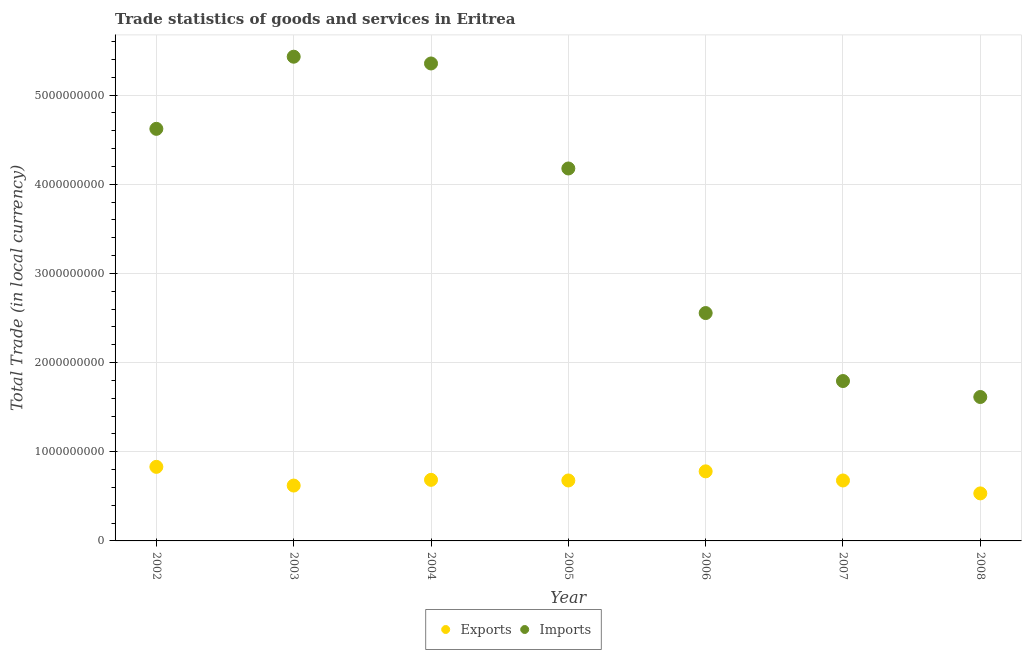Is the number of dotlines equal to the number of legend labels?
Provide a short and direct response. Yes. What is the imports of goods and services in 2005?
Provide a succinct answer. 4.18e+09. Across all years, what is the maximum export of goods and services?
Give a very brief answer. 8.31e+08. Across all years, what is the minimum imports of goods and services?
Ensure brevity in your answer.  1.61e+09. What is the total imports of goods and services in the graph?
Your answer should be compact. 2.55e+1. What is the difference between the export of goods and services in 2005 and that in 2006?
Make the answer very short. -1.02e+08. What is the difference between the imports of goods and services in 2003 and the export of goods and services in 2007?
Provide a short and direct response. 4.75e+09. What is the average imports of goods and services per year?
Your response must be concise. 3.65e+09. In the year 2006, what is the difference between the export of goods and services and imports of goods and services?
Your response must be concise. -1.78e+09. What is the ratio of the imports of goods and services in 2006 to that in 2008?
Your response must be concise. 1.58. Is the export of goods and services in 2002 less than that in 2007?
Offer a very short reply. No. What is the difference between the highest and the second highest imports of goods and services?
Your answer should be very brief. 7.59e+07. What is the difference between the highest and the lowest export of goods and services?
Your response must be concise. 2.98e+08. Is the sum of the imports of goods and services in 2003 and 2007 greater than the maximum export of goods and services across all years?
Your answer should be compact. Yes. Is the imports of goods and services strictly greater than the export of goods and services over the years?
Give a very brief answer. Yes. Is the export of goods and services strictly less than the imports of goods and services over the years?
Ensure brevity in your answer.  Yes. Are the values on the major ticks of Y-axis written in scientific E-notation?
Make the answer very short. No. Does the graph contain grids?
Provide a short and direct response. Yes. Where does the legend appear in the graph?
Ensure brevity in your answer.  Bottom center. How many legend labels are there?
Your response must be concise. 2. How are the legend labels stacked?
Make the answer very short. Horizontal. What is the title of the graph?
Provide a short and direct response. Trade statistics of goods and services in Eritrea. Does "Girls" appear as one of the legend labels in the graph?
Your response must be concise. No. What is the label or title of the X-axis?
Your response must be concise. Year. What is the label or title of the Y-axis?
Offer a terse response. Total Trade (in local currency). What is the Total Trade (in local currency) of Exports in 2002?
Your answer should be very brief. 8.31e+08. What is the Total Trade (in local currency) in Imports in 2002?
Your answer should be compact. 4.62e+09. What is the Total Trade (in local currency) in Exports in 2003?
Make the answer very short. 6.21e+08. What is the Total Trade (in local currency) of Imports in 2003?
Offer a very short reply. 5.43e+09. What is the Total Trade (in local currency) of Exports in 2004?
Provide a short and direct response. 6.85e+08. What is the Total Trade (in local currency) in Imports in 2004?
Provide a short and direct response. 5.35e+09. What is the Total Trade (in local currency) of Exports in 2005?
Offer a terse response. 6.78e+08. What is the Total Trade (in local currency) of Imports in 2005?
Offer a very short reply. 4.18e+09. What is the Total Trade (in local currency) in Exports in 2006?
Ensure brevity in your answer.  7.80e+08. What is the Total Trade (in local currency) of Imports in 2006?
Provide a short and direct response. 2.56e+09. What is the Total Trade (in local currency) of Exports in 2007?
Your response must be concise. 6.78e+08. What is the Total Trade (in local currency) in Imports in 2007?
Provide a short and direct response. 1.79e+09. What is the Total Trade (in local currency) of Exports in 2008?
Keep it short and to the point. 5.33e+08. What is the Total Trade (in local currency) of Imports in 2008?
Ensure brevity in your answer.  1.61e+09. Across all years, what is the maximum Total Trade (in local currency) of Exports?
Make the answer very short. 8.31e+08. Across all years, what is the maximum Total Trade (in local currency) of Imports?
Make the answer very short. 5.43e+09. Across all years, what is the minimum Total Trade (in local currency) of Exports?
Provide a succinct answer. 5.33e+08. Across all years, what is the minimum Total Trade (in local currency) of Imports?
Your response must be concise. 1.61e+09. What is the total Total Trade (in local currency) in Exports in the graph?
Ensure brevity in your answer.  4.81e+09. What is the total Total Trade (in local currency) of Imports in the graph?
Ensure brevity in your answer.  2.55e+1. What is the difference between the Total Trade (in local currency) in Exports in 2002 and that in 2003?
Provide a succinct answer. 2.10e+08. What is the difference between the Total Trade (in local currency) in Imports in 2002 and that in 2003?
Ensure brevity in your answer.  -8.09e+08. What is the difference between the Total Trade (in local currency) in Exports in 2002 and that in 2004?
Your response must be concise. 1.46e+08. What is the difference between the Total Trade (in local currency) in Imports in 2002 and that in 2004?
Provide a short and direct response. -7.33e+08. What is the difference between the Total Trade (in local currency) of Exports in 2002 and that in 2005?
Keep it short and to the point. 1.53e+08. What is the difference between the Total Trade (in local currency) in Imports in 2002 and that in 2005?
Provide a succinct answer. 4.44e+08. What is the difference between the Total Trade (in local currency) of Exports in 2002 and that in 2006?
Your answer should be compact. 5.03e+07. What is the difference between the Total Trade (in local currency) in Imports in 2002 and that in 2006?
Your answer should be compact. 2.07e+09. What is the difference between the Total Trade (in local currency) in Exports in 2002 and that in 2007?
Provide a succinct answer. 1.53e+08. What is the difference between the Total Trade (in local currency) in Imports in 2002 and that in 2007?
Your response must be concise. 2.83e+09. What is the difference between the Total Trade (in local currency) of Exports in 2002 and that in 2008?
Ensure brevity in your answer.  2.98e+08. What is the difference between the Total Trade (in local currency) of Imports in 2002 and that in 2008?
Your answer should be very brief. 3.01e+09. What is the difference between the Total Trade (in local currency) in Exports in 2003 and that in 2004?
Keep it short and to the point. -6.41e+07. What is the difference between the Total Trade (in local currency) in Imports in 2003 and that in 2004?
Offer a very short reply. 7.59e+07. What is the difference between the Total Trade (in local currency) of Exports in 2003 and that in 2005?
Give a very brief answer. -5.71e+07. What is the difference between the Total Trade (in local currency) in Imports in 2003 and that in 2005?
Offer a terse response. 1.25e+09. What is the difference between the Total Trade (in local currency) of Exports in 2003 and that in 2006?
Ensure brevity in your answer.  -1.59e+08. What is the difference between the Total Trade (in local currency) in Imports in 2003 and that in 2006?
Give a very brief answer. 2.88e+09. What is the difference between the Total Trade (in local currency) in Exports in 2003 and that in 2007?
Provide a short and direct response. -5.70e+07. What is the difference between the Total Trade (in local currency) of Imports in 2003 and that in 2007?
Provide a short and direct response. 3.64e+09. What is the difference between the Total Trade (in local currency) in Exports in 2003 and that in 2008?
Your answer should be very brief. 8.79e+07. What is the difference between the Total Trade (in local currency) in Imports in 2003 and that in 2008?
Provide a short and direct response. 3.82e+09. What is the difference between the Total Trade (in local currency) in Exports in 2004 and that in 2005?
Provide a short and direct response. 7.06e+06. What is the difference between the Total Trade (in local currency) of Imports in 2004 and that in 2005?
Give a very brief answer. 1.18e+09. What is the difference between the Total Trade (in local currency) in Exports in 2004 and that in 2006?
Your answer should be compact. -9.53e+07. What is the difference between the Total Trade (in local currency) of Imports in 2004 and that in 2006?
Give a very brief answer. 2.80e+09. What is the difference between the Total Trade (in local currency) of Exports in 2004 and that in 2007?
Make the answer very short. 7.15e+06. What is the difference between the Total Trade (in local currency) in Imports in 2004 and that in 2007?
Your answer should be very brief. 3.56e+09. What is the difference between the Total Trade (in local currency) of Exports in 2004 and that in 2008?
Provide a succinct answer. 1.52e+08. What is the difference between the Total Trade (in local currency) in Imports in 2004 and that in 2008?
Your answer should be compact. 3.74e+09. What is the difference between the Total Trade (in local currency) in Exports in 2005 and that in 2006?
Offer a very short reply. -1.02e+08. What is the difference between the Total Trade (in local currency) in Imports in 2005 and that in 2006?
Ensure brevity in your answer.  1.62e+09. What is the difference between the Total Trade (in local currency) in Exports in 2005 and that in 2007?
Your answer should be very brief. 9.37e+04. What is the difference between the Total Trade (in local currency) in Imports in 2005 and that in 2007?
Keep it short and to the point. 2.38e+09. What is the difference between the Total Trade (in local currency) of Exports in 2005 and that in 2008?
Provide a short and direct response. 1.45e+08. What is the difference between the Total Trade (in local currency) in Imports in 2005 and that in 2008?
Provide a succinct answer. 2.56e+09. What is the difference between the Total Trade (in local currency) of Exports in 2006 and that in 2007?
Offer a terse response. 1.02e+08. What is the difference between the Total Trade (in local currency) in Imports in 2006 and that in 2007?
Provide a succinct answer. 7.62e+08. What is the difference between the Total Trade (in local currency) of Exports in 2006 and that in 2008?
Give a very brief answer. 2.47e+08. What is the difference between the Total Trade (in local currency) of Imports in 2006 and that in 2008?
Offer a very short reply. 9.41e+08. What is the difference between the Total Trade (in local currency) in Exports in 2007 and that in 2008?
Offer a very short reply. 1.45e+08. What is the difference between the Total Trade (in local currency) in Imports in 2007 and that in 2008?
Offer a terse response. 1.79e+08. What is the difference between the Total Trade (in local currency) of Exports in 2002 and the Total Trade (in local currency) of Imports in 2003?
Provide a succinct answer. -4.60e+09. What is the difference between the Total Trade (in local currency) of Exports in 2002 and the Total Trade (in local currency) of Imports in 2004?
Offer a very short reply. -4.52e+09. What is the difference between the Total Trade (in local currency) in Exports in 2002 and the Total Trade (in local currency) in Imports in 2005?
Ensure brevity in your answer.  -3.35e+09. What is the difference between the Total Trade (in local currency) in Exports in 2002 and the Total Trade (in local currency) in Imports in 2006?
Ensure brevity in your answer.  -1.72e+09. What is the difference between the Total Trade (in local currency) of Exports in 2002 and the Total Trade (in local currency) of Imports in 2007?
Your answer should be very brief. -9.62e+08. What is the difference between the Total Trade (in local currency) in Exports in 2002 and the Total Trade (in local currency) in Imports in 2008?
Provide a succinct answer. -7.83e+08. What is the difference between the Total Trade (in local currency) of Exports in 2003 and the Total Trade (in local currency) of Imports in 2004?
Your answer should be compact. -4.73e+09. What is the difference between the Total Trade (in local currency) in Exports in 2003 and the Total Trade (in local currency) in Imports in 2005?
Offer a terse response. -3.56e+09. What is the difference between the Total Trade (in local currency) of Exports in 2003 and the Total Trade (in local currency) of Imports in 2006?
Ensure brevity in your answer.  -1.93e+09. What is the difference between the Total Trade (in local currency) of Exports in 2003 and the Total Trade (in local currency) of Imports in 2007?
Provide a short and direct response. -1.17e+09. What is the difference between the Total Trade (in local currency) of Exports in 2003 and the Total Trade (in local currency) of Imports in 2008?
Offer a very short reply. -9.93e+08. What is the difference between the Total Trade (in local currency) of Exports in 2004 and the Total Trade (in local currency) of Imports in 2005?
Make the answer very short. -3.49e+09. What is the difference between the Total Trade (in local currency) in Exports in 2004 and the Total Trade (in local currency) in Imports in 2006?
Give a very brief answer. -1.87e+09. What is the difference between the Total Trade (in local currency) in Exports in 2004 and the Total Trade (in local currency) in Imports in 2007?
Your response must be concise. -1.11e+09. What is the difference between the Total Trade (in local currency) in Exports in 2004 and the Total Trade (in local currency) in Imports in 2008?
Offer a very short reply. -9.29e+08. What is the difference between the Total Trade (in local currency) in Exports in 2005 and the Total Trade (in local currency) in Imports in 2006?
Your answer should be very brief. -1.88e+09. What is the difference between the Total Trade (in local currency) of Exports in 2005 and the Total Trade (in local currency) of Imports in 2007?
Offer a very short reply. -1.12e+09. What is the difference between the Total Trade (in local currency) of Exports in 2005 and the Total Trade (in local currency) of Imports in 2008?
Ensure brevity in your answer.  -9.36e+08. What is the difference between the Total Trade (in local currency) in Exports in 2006 and the Total Trade (in local currency) in Imports in 2007?
Provide a succinct answer. -1.01e+09. What is the difference between the Total Trade (in local currency) in Exports in 2006 and the Total Trade (in local currency) in Imports in 2008?
Your answer should be very brief. -8.34e+08. What is the difference between the Total Trade (in local currency) of Exports in 2007 and the Total Trade (in local currency) of Imports in 2008?
Your answer should be very brief. -9.36e+08. What is the average Total Trade (in local currency) of Exports per year?
Ensure brevity in your answer.  6.87e+08. What is the average Total Trade (in local currency) of Imports per year?
Keep it short and to the point. 3.65e+09. In the year 2002, what is the difference between the Total Trade (in local currency) of Exports and Total Trade (in local currency) of Imports?
Give a very brief answer. -3.79e+09. In the year 2003, what is the difference between the Total Trade (in local currency) of Exports and Total Trade (in local currency) of Imports?
Provide a short and direct response. -4.81e+09. In the year 2004, what is the difference between the Total Trade (in local currency) of Exports and Total Trade (in local currency) of Imports?
Provide a succinct answer. -4.67e+09. In the year 2005, what is the difference between the Total Trade (in local currency) of Exports and Total Trade (in local currency) of Imports?
Provide a short and direct response. -3.50e+09. In the year 2006, what is the difference between the Total Trade (in local currency) in Exports and Total Trade (in local currency) in Imports?
Give a very brief answer. -1.78e+09. In the year 2007, what is the difference between the Total Trade (in local currency) in Exports and Total Trade (in local currency) in Imports?
Give a very brief answer. -1.12e+09. In the year 2008, what is the difference between the Total Trade (in local currency) of Exports and Total Trade (in local currency) of Imports?
Offer a very short reply. -1.08e+09. What is the ratio of the Total Trade (in local currency) of Exports in 2002 to that in 2003?
Your response must be concise. 1.34. What is the ratio of the Total Trade (in local currency) of Imports in 2002 to that in 2003?
Your answer should be compact. 0.85. What is the ratio of the Total Trade (in local currency) of Exports in 2002 to that in 2004?
Your answer should be very brief. 1.21. What is the ratio of the Total Trade (in local currency) of Imports in 2002 to that in 2004?
Your response must be concise. 0.86. What is the ratio of the Total Trade (in local currency) in Exports in 2002 to that in 2005?
Your response must be concise. 1.23. What is the ratio of the Total Trade (in local currency) of Imports in 2002 to that in 2005?
Ensure brevity in your answer.  1.11. What is the ratio of the Total Trade (in local currency) of Exports in 2002 to that in 2006?
Your answer should be very brief. 1.06. What is the ratio of the Total Trade (in local currency) of Imports in 2002 to that in 2006?
Offer a very short reply. 1.81. What is the ratio of the Total Trade (in local currency) of Exports in 2002 to that in 2007?
Your answer should be compact. 1.23. What is the ratio of the Total Trade (in local currency) in Imports in 2002 to that in 2007?
Keep it short and to the point. 2.58. What is the ratio of the Total Trade (in local currency) of Exports in 2002 to that in 2008?
Make the answer very short. 1.56. What is the ratio of the Total Trade (in local currency) of Imports in 2002 to that in 2008?
Offer a very short reply. 2.86. What is the ratio of the Total Trade (in local currency) in Exports in 2003 to that in 2004?
Your response must be concise. 0.91. What is the ratio of the Total Trade (in local currency) of Imports in 2003 to that in 2004?
Keep it short and to the point. 1.01. What is the ratio of the Total Trade (in local currency) in Exports in 2003 to that in 2005?
Make the answer very short. 0.92. What is the ratio of the Total Trade (in local currency) in Imports in 2003 to that in 2005?
Your response must be concise. 1.3. What is the ratio of the Total Trade (in local currency) of Exports in 2003 to that in 2006?
Offer a very short reply. 0.8. What is the ratio of the Total Trade (in local currency) of Imports in 2003 to that in 2006?
Make the answer very short. 2.12. What is the ratio of the Total Trade (in local currency) in Exports in 2003 to that in 2007?
Offer a very short reply. 0.92. What is the ratio of the Total Trade (in local currency) of Imports in 2003 to that in 2007?
Offer a very short reply. 3.03. What is the ratio of the Total Trade (in local currency) in Exports in 2003 to that in 2008?
Your answer should be compact. 1.16. What is the ratio of the Total Trade (in local currency) in Imports in 2003 to that in 2008?
Offer a terse response. 3.36. What is the ratio of the Total Trade (in local currency) of Exports in 2004 to that in 2005?
Provide a short and direct response. 1.01. What is the ratio of the Total Trade (in local currency) of Imports in 2004 to that in 2005?
Provide a succinct answer. 1.28. What is the ratio of the Total Trade (in local currency) in Exports in 2004 to that in 2006?
Make the answer very short. 0.88. What is the ratio of the Total Trade (in local currency) of Imports in 2004 to that in 2006?
Provide a succinct answer. 2.1. What is the ratio of the Total Trade (in local currency) in Exports in 2004 to that in 2007?
Ensure brevity in your answer.  1.01. What is the ratio of the Total Trade (in local currency) of Imports in 2004 to that in 2007?
Offer a terse response. 2.99. What is the ratio of the Total Trade (in local currency) in Exports in 2004 to that in 2008?
Keep it short and to the point. 1.29. What is the ratio of the Total Trade (in local currency) in Imports in 2004 to that in 2008?
Your answer should be compact. 3.32. What is the ratio of the Total Trade (in local currency) of Exports in 2005 to that in 2006?
Ensure brevity in your answer.  0.87. What is the ratio of the Total Trade (in local currency) of Imports in 2005 to that in 2006?
Give a very brief answer. 1.63. What is the ratio of the Total Trade (in local currency) of Imports in 2005 to that in 2007?
Your response must be concise. 2.33. What is the ratio of the Total Trade (in local currency) of Exports in 2005 to that in 2008?
Offer a terse response. 1.27. What is the ratio of the Total Trade (in local currency) of Imports in 2005 to that in 2008?
Give a very brief answer. 2.59. What is the ratio of the Total Trade (in local currency) of Exports in 2006 to that in 2007?
Keep it short and to the point. 1.15. What is the ratio of the Total Trade (in local currency) of Imports in 2006 to that in 2007?
Provide a succinct answer. 1.43. What is the ratio of the Total Trade (in local currency) of Exports in 2006 to that in 2008?
Your answer should be compact. 1.46. What is the ratio of the Total Trade (in local currency) of Imports in 2006 to that in 2008?
Keep it short and to the point. 1.58. What is the ratio of the Total Trade (in local currency) in Exports in 2007 to that in 2008?
Make the answer very short. 1.27. What is the ratio of the Total Trade (in local currency) of Imports in 2007 to that in 2008?
Keep it short and to the point. 1.11. What is the difference between the highest and the second highest Total Trade (in local currency) in Exports?
Make the answer very short. 5.03e+07. What is the difference between the highest and the second highest Total Trade (in local currency) in Imports?
Provide a short and direct response. 7.59e+07. What is the difference between the highest and the lowest Total Trade (in local currency) in Exports?
Give a very brief answer. 2.98e+08. What is the difference between the highest and the lowest Total Trade (in local currency) of Imports?
Give a very brief answer. 3.82e+09. 